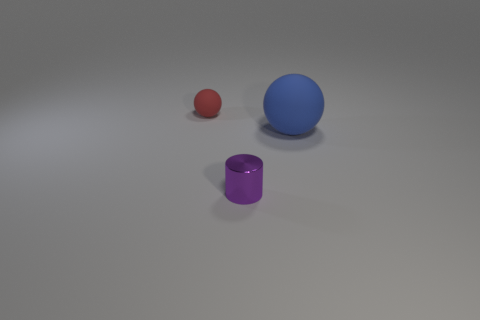Are there the same number of big rubber spheres on the left side of the purple metallic thing and large gray spheres?
Make the answer very short. Yes. What number of cylinders are either red objects or blue objects?
Your answer should be very brief. 0. Is the tiny ball the same color as the small cylinder?
Offer a terse response. No. Are there the same number of rubber objects that are to the right of the tiny metallic cylinder and cylinders that are behind the big blue object?
Provide a succinct answer. No. What color is the tiny matte thing?
Make the answer very short. Red. How many things are objects that are behind the cylinder or red spheres?
Your answer should be compact. 2. Do the object in front of the big blue matte ball and the ball that is right of the small red rubber ball have the same size?
Offer a terse response. No. Are there any other things that are the same material as the red sphere?
Provide a succinct answer. Yes. How many things are matte spheres that are to the right of the tiny matte thing or rubber balls that are on the right side of the tiny metallic object?
Keep it short and to the point. 1. Do the tiny red ball and the ball to the right of the purple metallic object have the same material?
Offer a terse response. Yes. 